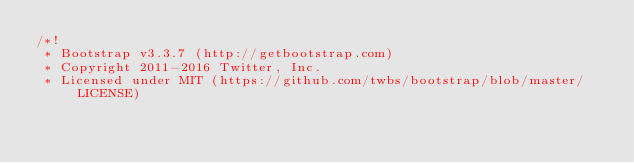<code> <loc_0><loc_0><loc_500><loc_500><_CSS_>/*!
 * Bootstrap v3.3.7 (http://getbootstrap.com)
 * Copyright 2011-2016 Twitter, Inc.
 * Licensed under MIT (https://github.com/twbs/bootstrap/blob/master/LICENSE)</code> 